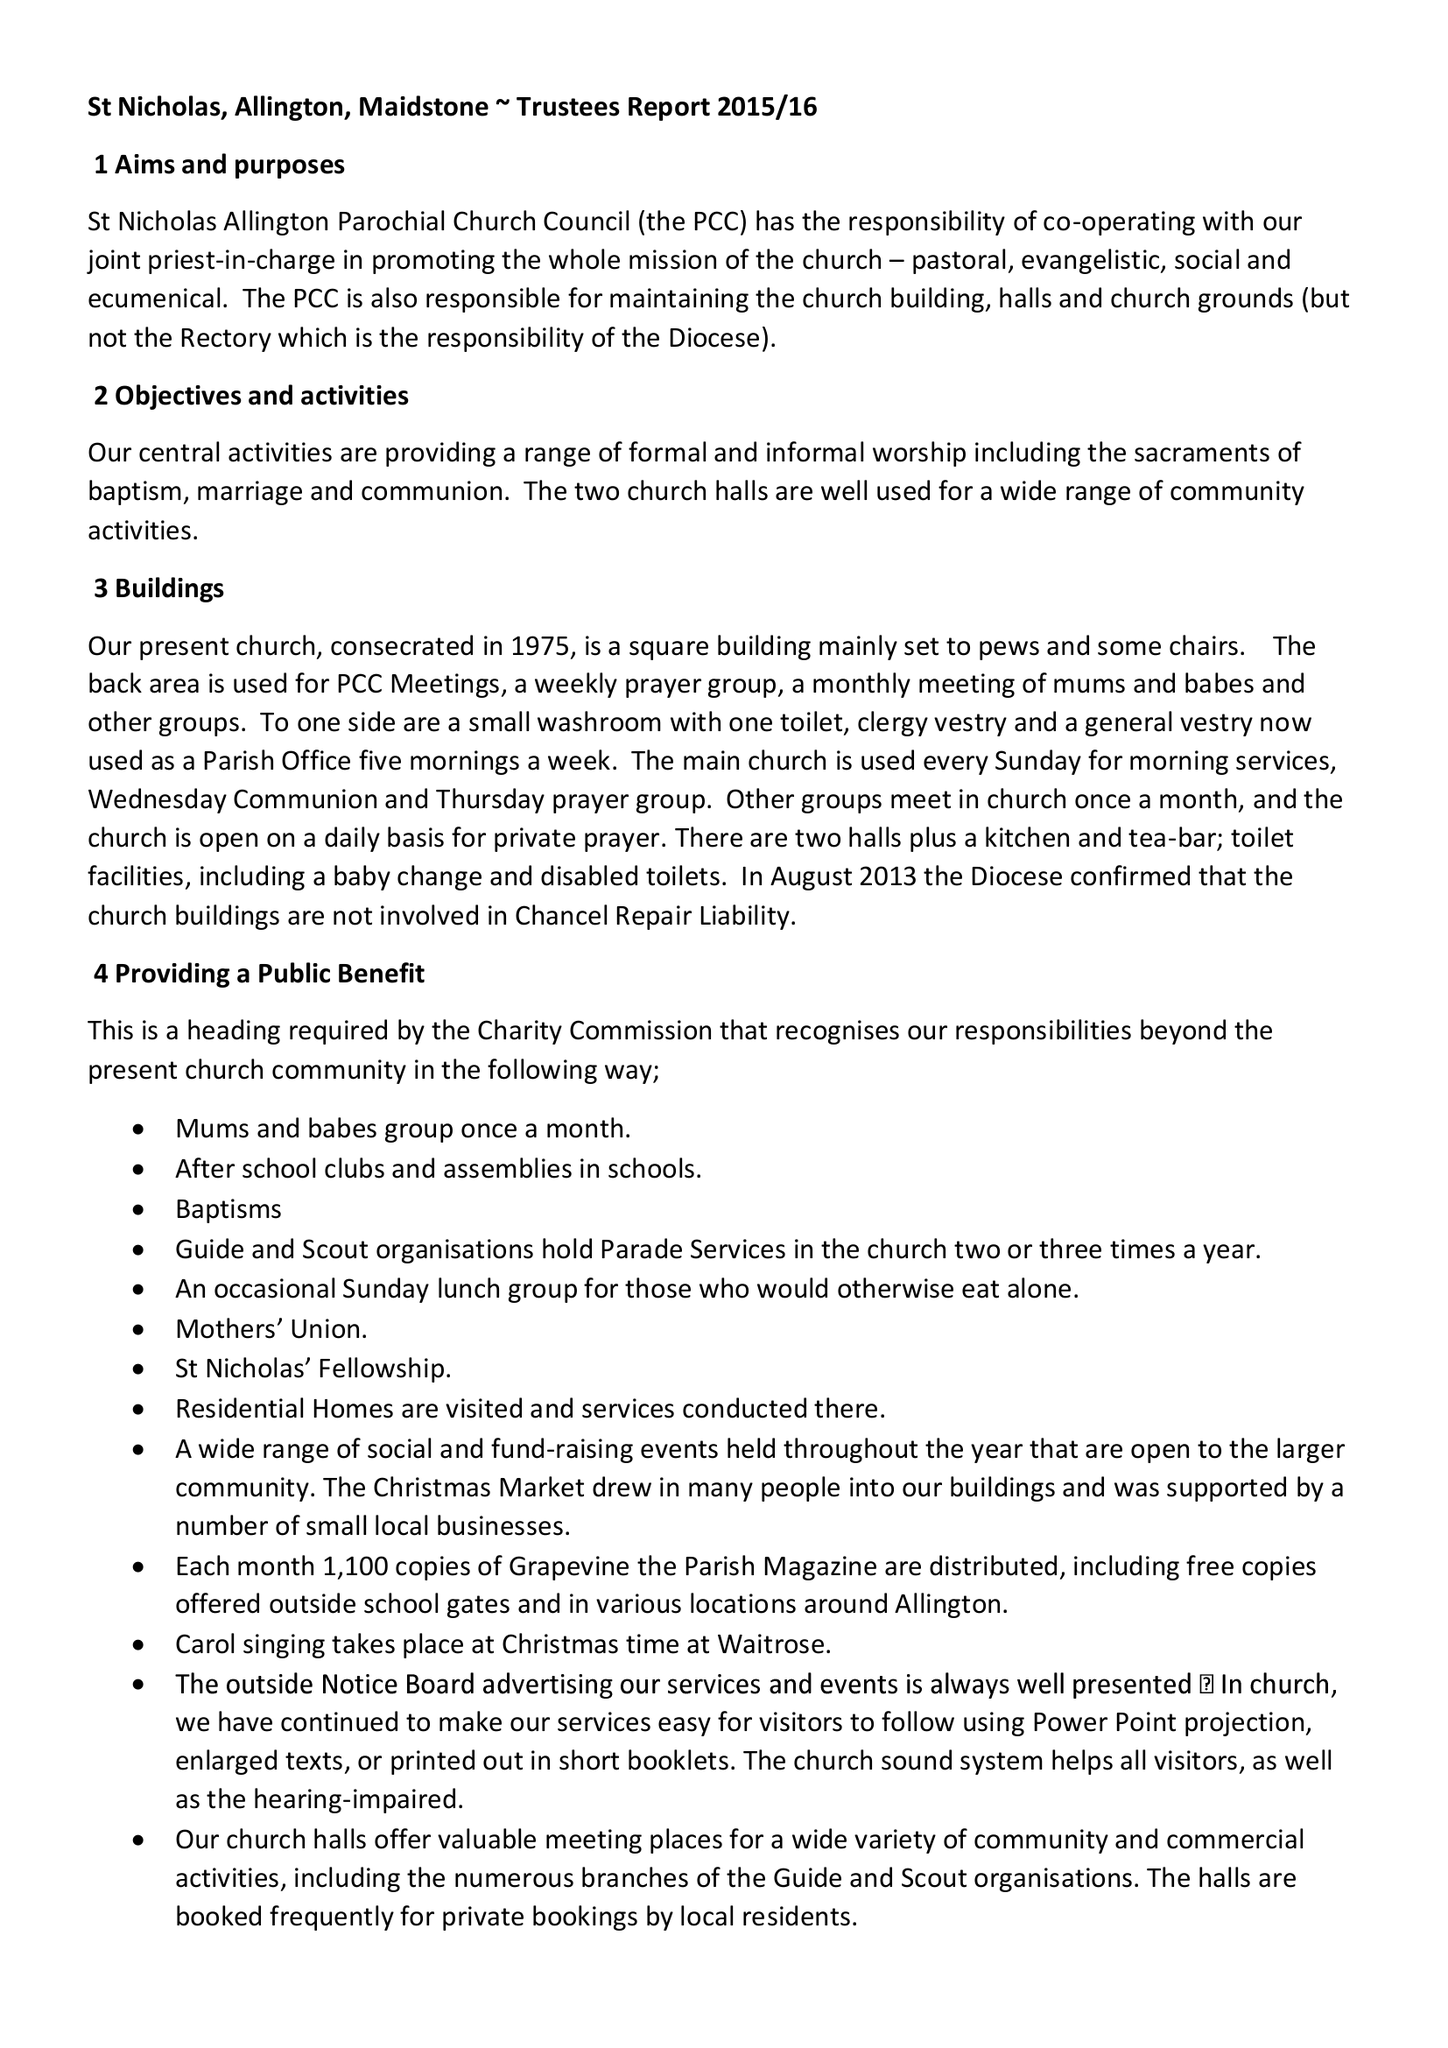What is the value for the charity_number?
Answer the question using a single word or phrase. 1155127 